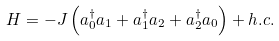Convert formula to latex. <formula><loc_0><loc_0><loc_500><loc_500>H = - J \left ( a _ { 0 } ^ { \dag } a _ { 1 } + a _ { 1 } ^ { \dag } a _ { 2 } + a _ { 2 } ^ { \dag } a _ { 0 } \right ) + h . c .</formula> 